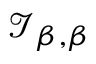Convert formula to latex. <formula><loc_0><loc_0><loc_500><loc_500>{ \mathcal { I } } _ { \beta , \beta }</formula> 